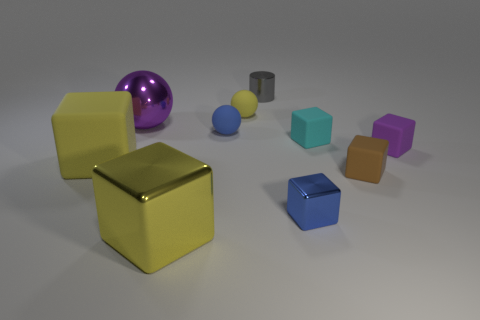What is the material of the block that is the same color as the large metallic ball?
Provide a succinct answer. Rubber. There is a purple object that is on the right side of the yellow cube that is right of the purple sphere; what number of purple rubber objects are in front of it?
Offer a very short reply. 0. How many tiny cyan rubber things are behind the yellow rubber block?
Your answer should be compact. 1. How many large objects have the same material as the small cylinder?
Your answer should be very brief. 2. The tiny cylinder that is the same material as the purple ball is what color?
Provide a succinct answer. Gray. The blue thing that is in front of the sphere that is in front of the sphere that is to the left of the blue matte thing is made of what material?
Offer a terse response. Metal. There is a yellow matte object that is behind the purple metallic object; does it have the same size as the blue metal thing?
Ensure brevity in your answer.  Yes. What number of large things are either blue shiny blocks or purple matte blocks?
Give a very brief answer. 0. Is there a tiny thing of the same color as the tiny cylinder?
Offer a terse response. No. There is a blue matte object that is the same size as the gray metal object; what is its shape?
Your response must be concise. Sphere. 